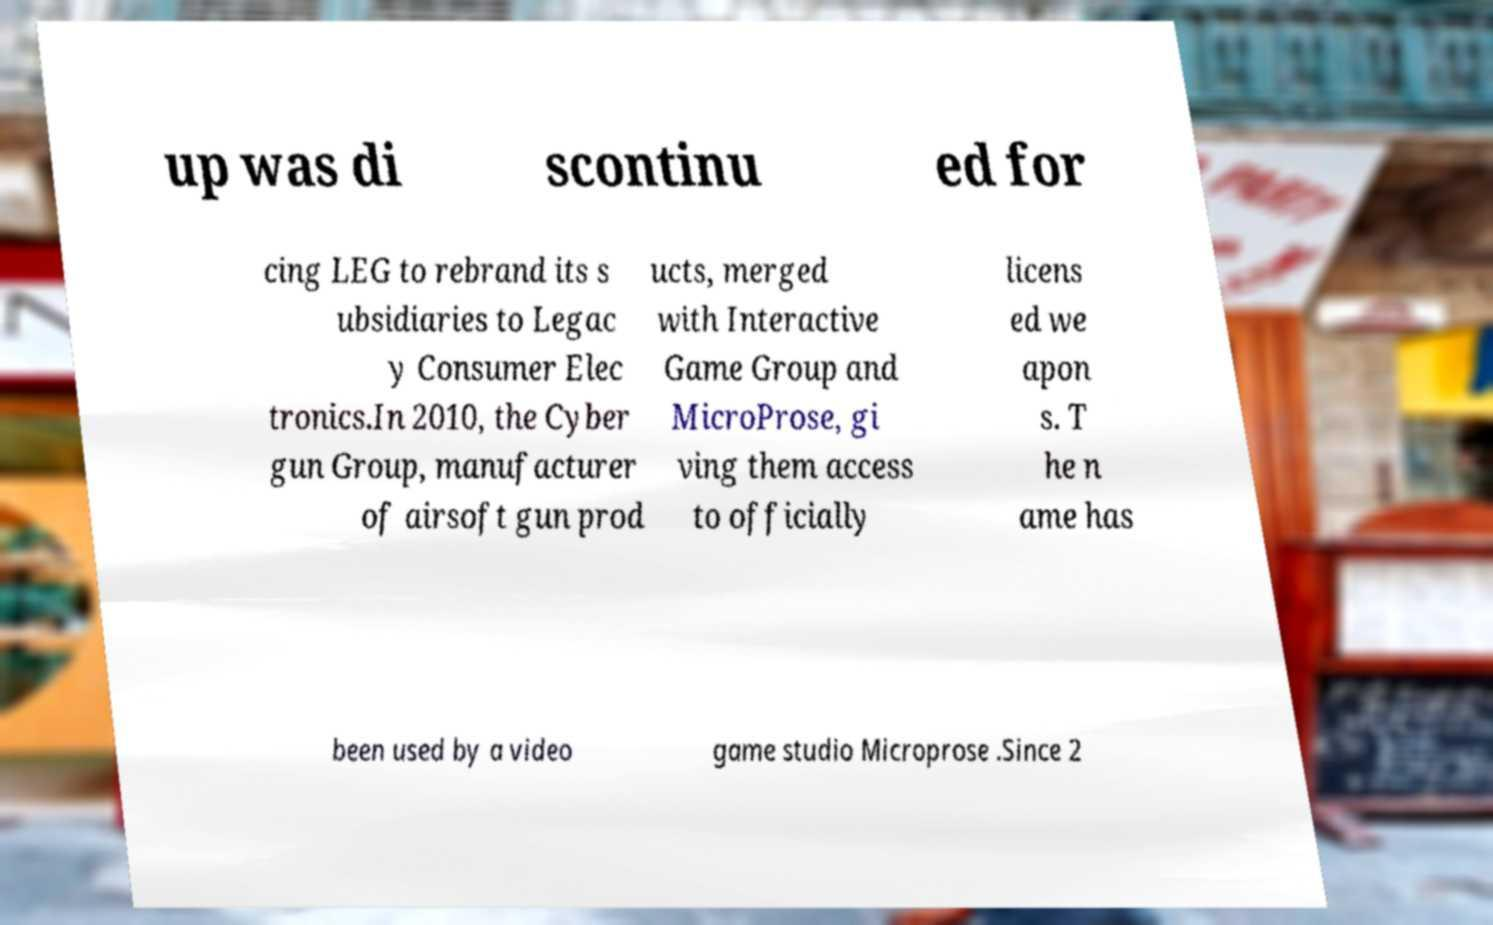Please read and relay the text visible in this image. What does it say? up was di scontinu ed for cing LEG to rebrand its s ubsidiaries to Legac y Consumer Elec tronics.In 2010, the Cyber gun Group, manufacturer of airsoft gun prod ucts, merged with Interactive Game Group and MicroProse, gi ving them access to officially licens ed we apon s. T he n ame has been used by a video game studio Microprose .Since 2 